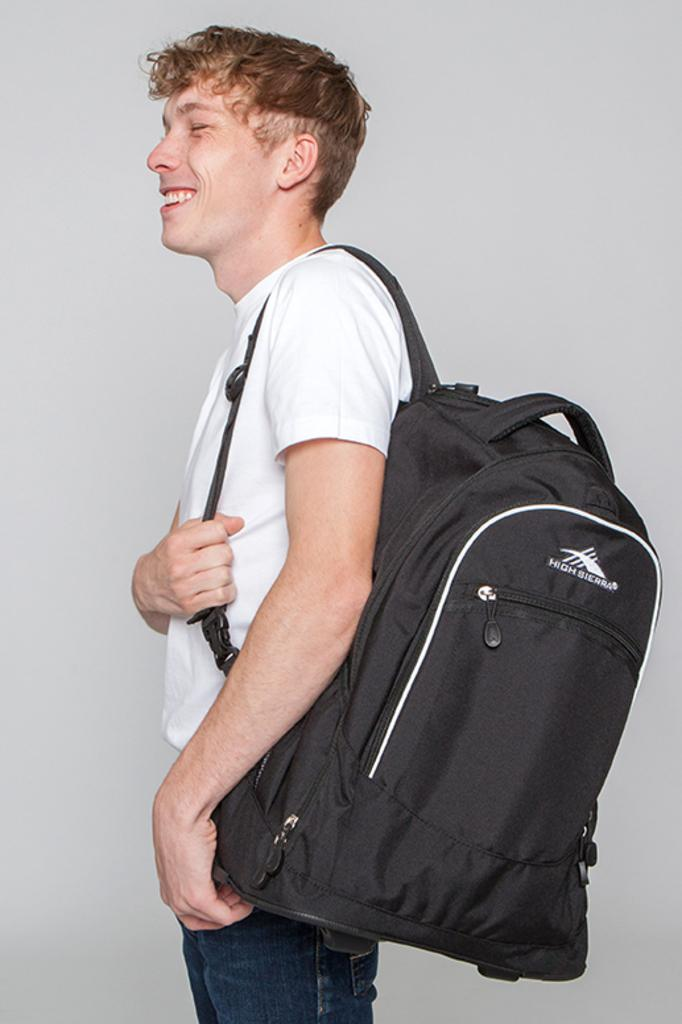Who is the main subject in the image? There is a man in the image. What is the man wearing on his upper body? The man is wearing a white t-shirt. What is the man wearing on his lower body? The man is wearing blue jeans. What type of bag is the man carrying? The man is wearing a black color bag. What is the man's facial expression in the image? The man is smiling. What type of doctor is the man pretending to be in the image? There is no indication in the image that the man is pretending to be a doctor. 